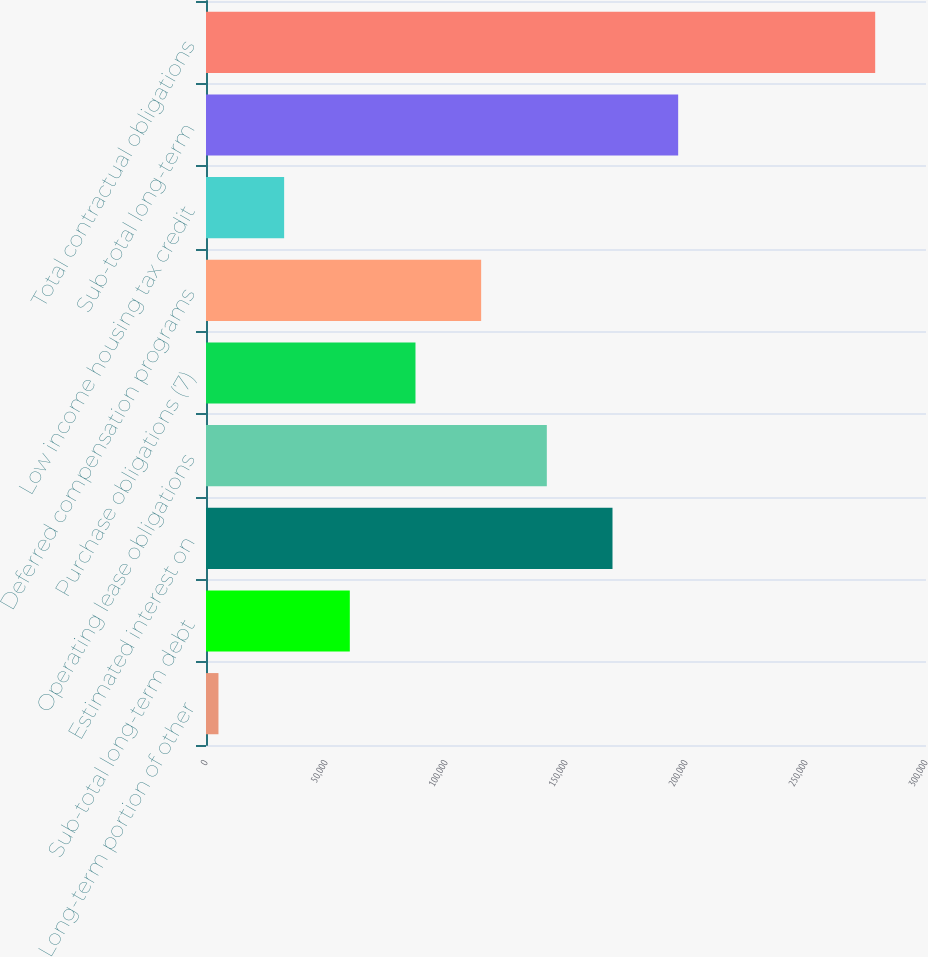Convert chart. <chart><loc_0><loc_0><loc_500><loc_500><bar_chart><fcel>Long-term portion of other<fcel>Sub-total long-term debt<fcel>Estimated interest on<fcel>Operating lease obligations<fcel>Purchase obligations (7)<fcel>Deferred compensation programs<fcel>Low income housing tax credit<fcel>Sub-total long-term<fcel>Total contractual obligations<nl><fcel>5195<fcel>59921.6<fcel>169375<fcel>142012<fcel>87284.9<fcel>114648<fcel>32558.3<fcel>196738<fcel>278828<nl></chart> 